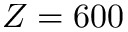Convert formula to latex. <formula><loc_0><loc_0><loc_500><loc_500>Z = 6 0 0</formula> 